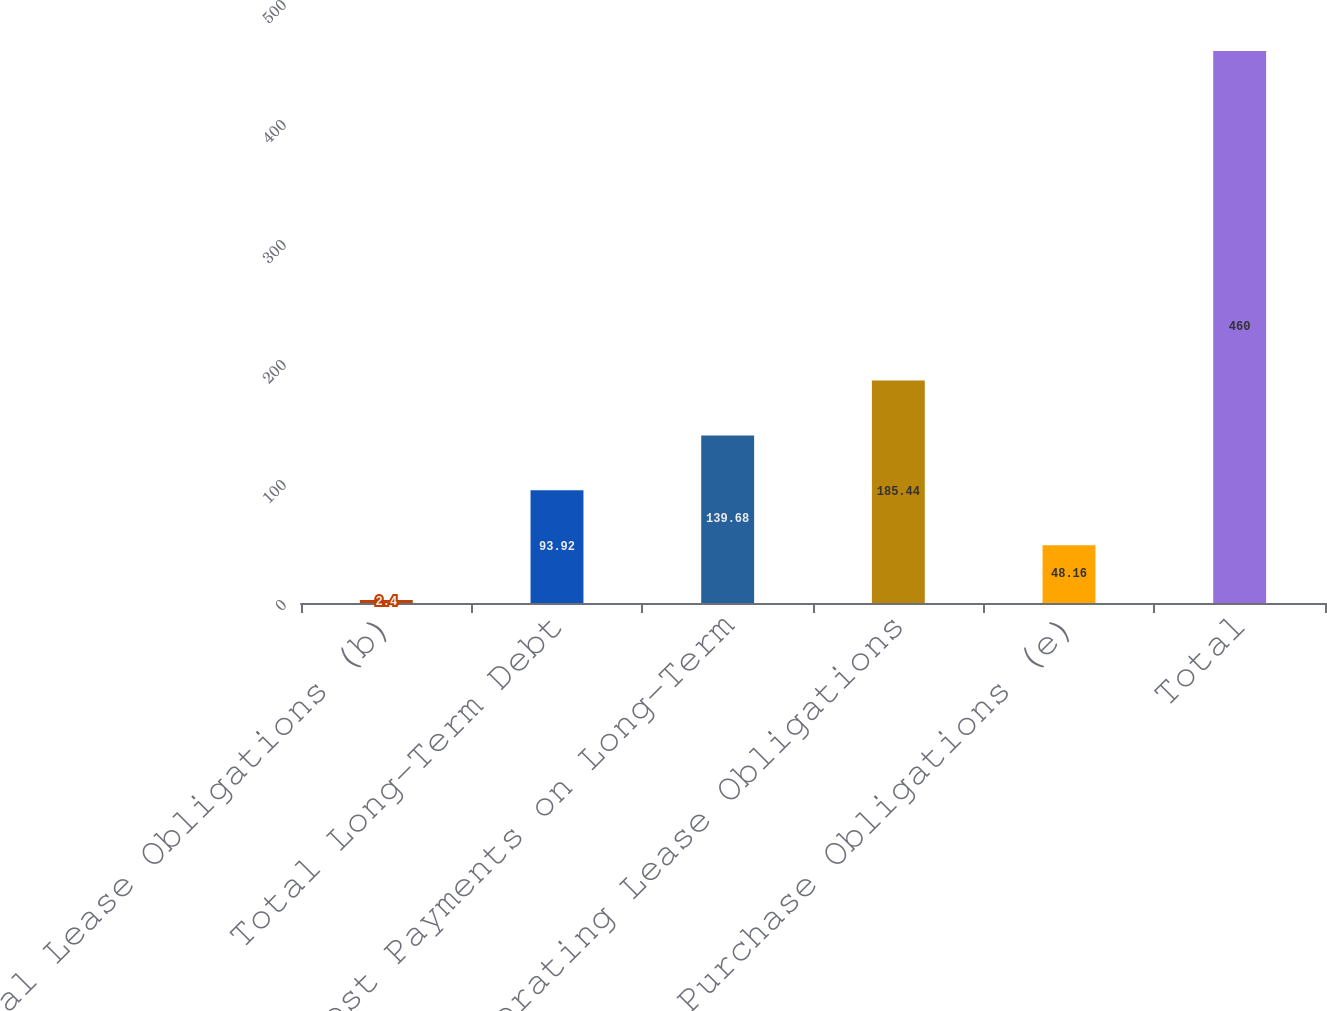Convert chart. <chart><loc_0><loc_0><loc_500><loc_500><bar_chart><fcel>Capital Lease Obligations (b)<fcel>Total Long-Term Debt<fcel>Interest Payments on Long-Term<fcel>Operating Lease Obligations<fcel>Purchase Obligations (e)<fcel>Total<nl><fcel>2.4<fcel>93.92<fcel>139.68<fcel>185.44<fcel>48.16<fcel>460<nl></chart> 